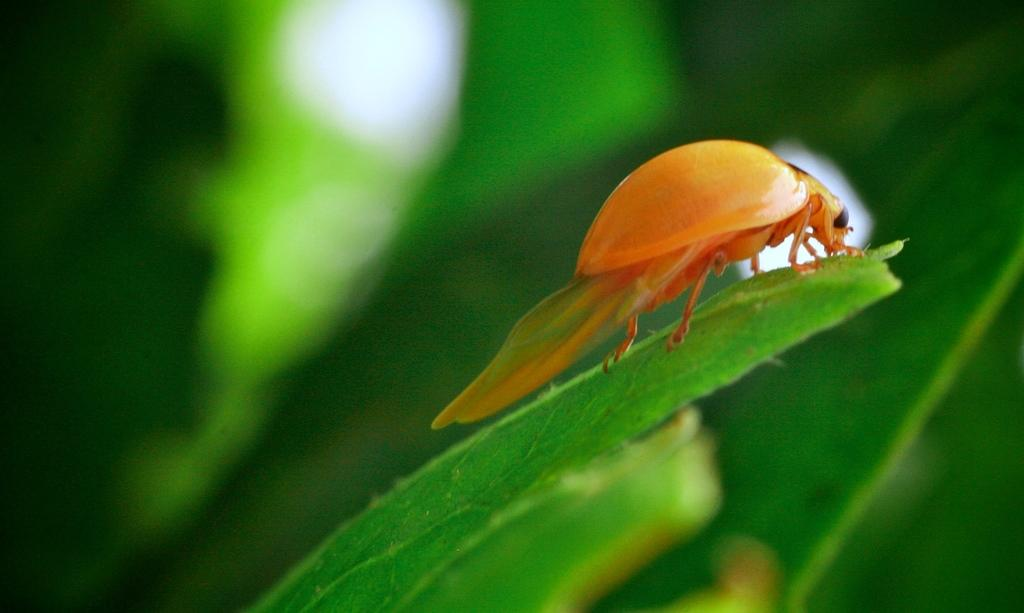What is present on the leaf in the image? There is an insect on the leaf in the image. Can you describe the insect's location in the image? The insect is on a leaf in the image. What can be observed about the background of the image? The background of the image is blurry. What type of flower is being rolled by the insect in the image? There is no flower present in the image, nor is the insect rolling anything. 